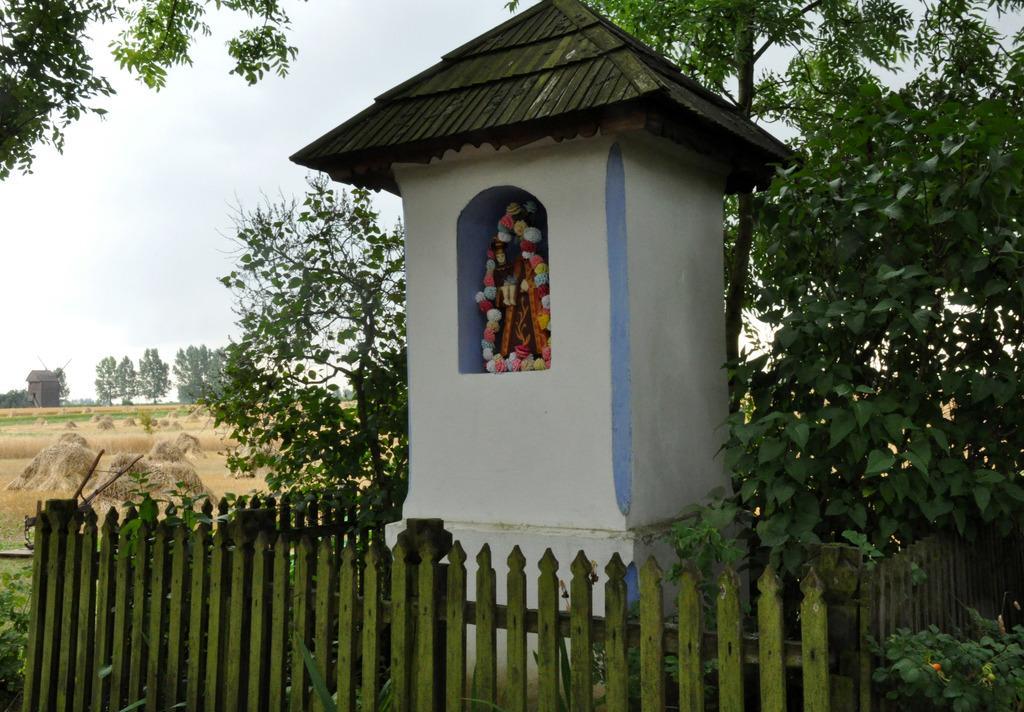Could you give a brief overview of what you see in this image? Here, we can idol of God place in the house, there is a fence, we can see some plants and trees, there is grass on the ground, at the top there is a sky. 